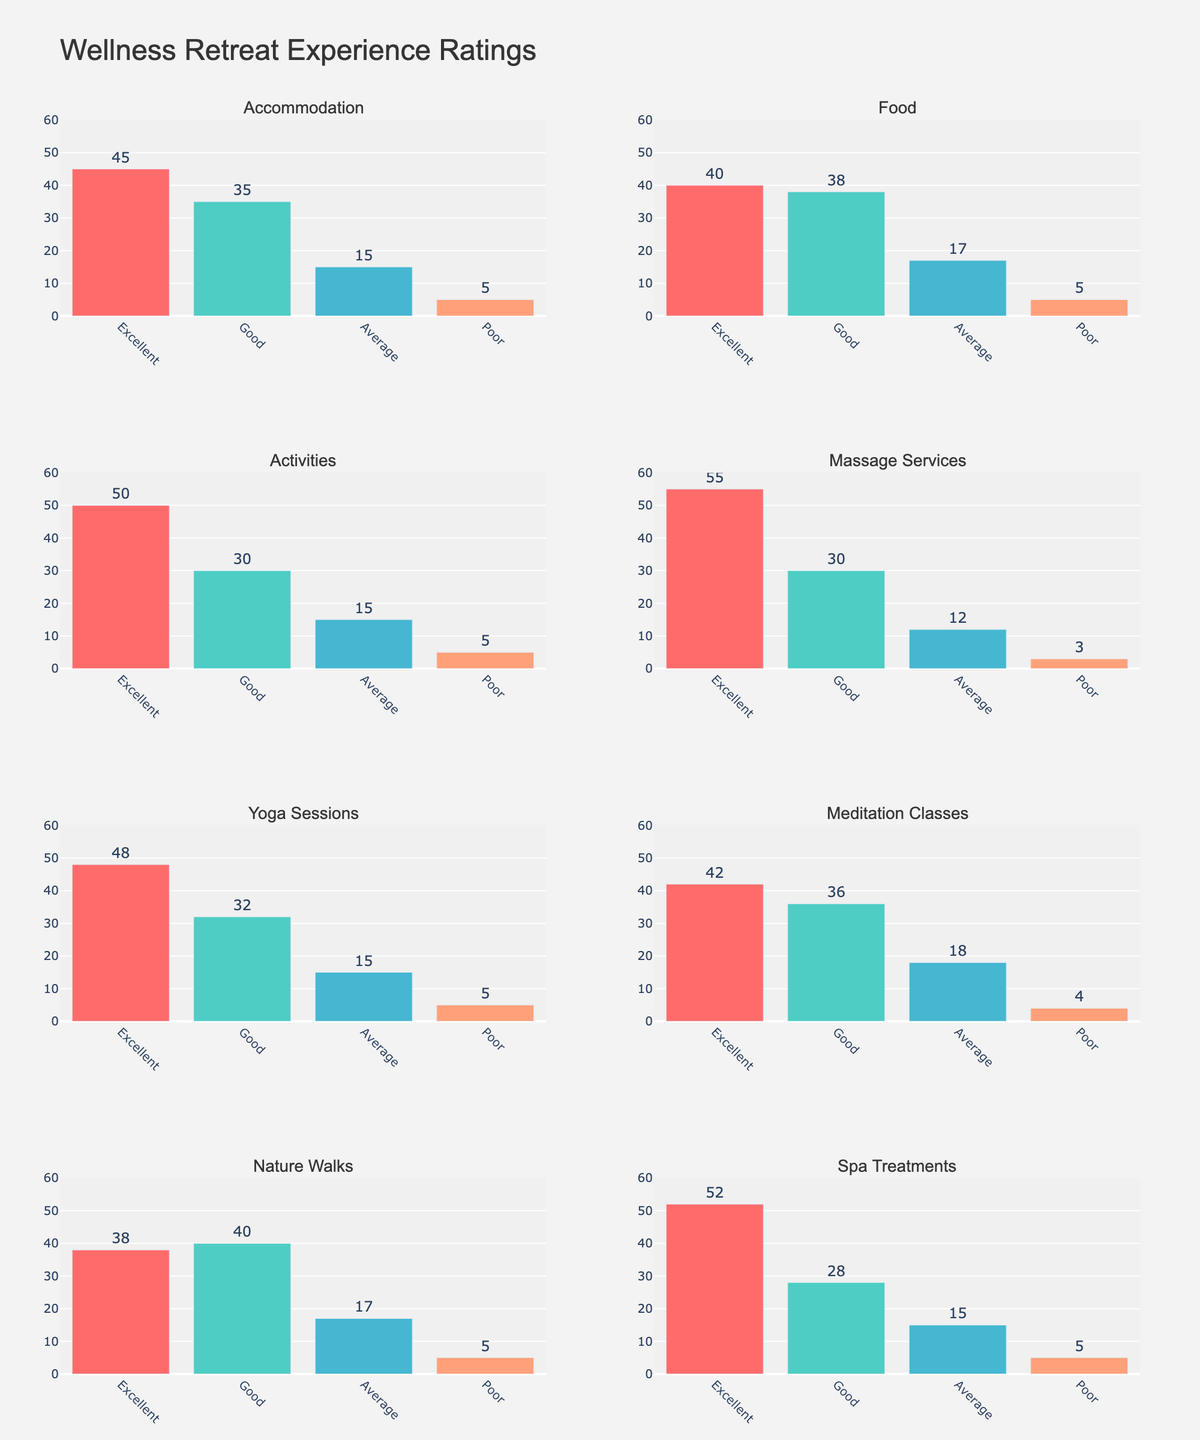What is the trend of bombing attacks in the Middle East from 2013 to 2022? The line chart for the Middle East shows the trend of bombing attacks. Observing the plot, there is a general downward trend from 2013 to 2022. The frequency starts at 312 in 2013 and decreases to 231 in 2022.
Answer: Downward trend In which year did North America see the highest number of cyber attacks? The bar chart for North America shows the number of cyber attacks each year. The highest bar in the chart is in the year 2022 with 59 attacks.
Answer: 2022 How do the number of hostage-taking incidents in Southeast Asia compare to maritime attacks in 2020? Looking at the area chart for Southeast Asia, the purple area represents hostage-taking and the orange area represents maritime attacks. In 2020, the number of hostage-taking incidents is 29 and maritime attacks are 11.
Answer: Hostage-taking is higher Which region experienced the most significant decline in terrorist attacks from 2013 to 2022, considering all types of attacks? Comparing all subplots, the Middle East shows a significant decline in bombing and armed assault attacks. Bombing decreased from 312 to 231, and armed assault from 189 to 132. This region has the highest total drop.
Answer: Middle East What is the dominant type of attack in Europe over the decade? By observing the line and bar charts for Europe, bombings have a consistently higher count compared to vehicle ramming. Bombings range from 23 to 61, whereas vehicle ramming is from 2 to 17.
Answer: Bombing What's the average number of mass shootings in North America across the decade? In the bar chart for North America, mass shootings are shown. The values are 16, 21, 25, 28, 30, 27, 24, 22, 19, and 17. Summing these values, we get 229. Dividing by 10 gives the average: 229 / 10 = 22.9.
Answer: 22.9 Between suicide bombings in Africa and cyber attacks in North America, which had a greater increase from 2013 to 2022? Suicide bombings in Africa started with 43 attacks in 2013 and ended with 32 attacks in 2022, actually showing a decrease. Cyber attacks in North America increased from 8 in 2013 to 59 in 2022.
Answer: Cyber attacks in North America What is the title of the figure? The overall title of the figure is displayed at the top of the plot. It reads "Terrorist Attack Frequency by Region and Type (2013-2022)."
Answer: Terrorist Attack Frequency by Region and Type (2013-2022) What was the total number of armed assaults in the Middle East in 2015 and 2016 combined? Referencing the line chart for the Middle East, the number of armed assaults in 2015 is 314 and in 2016 is 285. Adding these values: 314 + 285 = 599.
Answer: 599 How do the trends of kidnapping in Africa compare to vehicle ramming in Europe? Comparing Africa's line chart with Europe’s bar chart, kidnapping in Africa shows a gradual decline from 87 in 2013 to 85 in 2022. Vehicle ramming in Europe shows a rise in the middle years and a decline towards 2022 from 3 to 2.
Answer: Both show a decline 